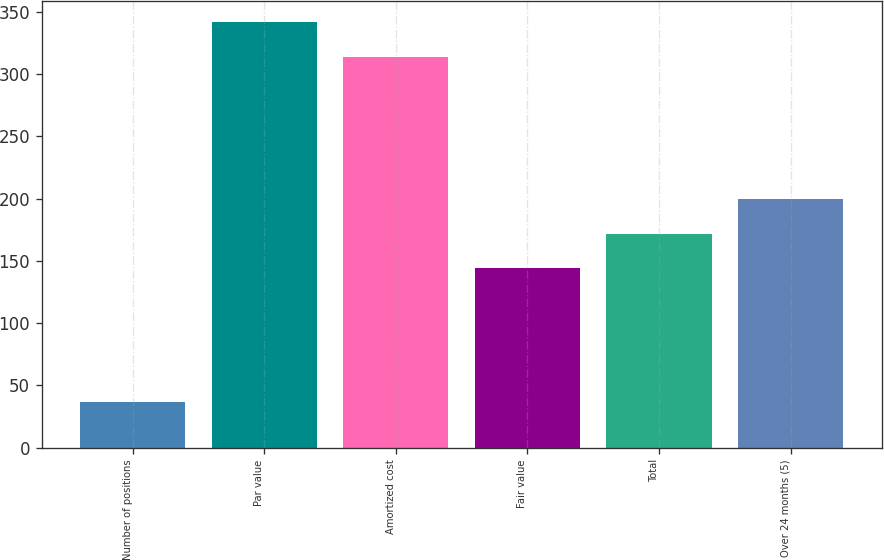Convert chart. <chart><loc_0><loc_0><loc_500><loc_500><bar_chart><fcel>Number of positions<fcel>Par value<fcel>Amortized cost<fcel>Fair value<fcel>Total<fcel>Over 24 months (5)<nl><fcel>37<fcel>341.8<fcel>314<fcel>144<fcel>171.8<fcel>199.6<nl></chart> 